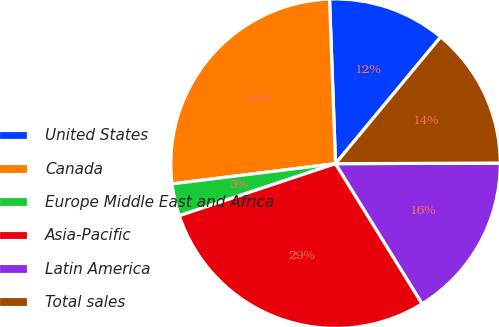Convert chart. <chart><loc_0><loc_0><loc_500><loc_500><pie_chart><fcel>United States<fcel>Canada<fcel>Europe Middle East and Africa<fcel>Asia-Pacific<fcel>Latin America<fcel>Total sales<nl><fcel>11.6%<fcel>26.37%<fcel>3.16%<fcel>28.69%<fcel>16.24%<fcel>13.92%<nl></chart> 